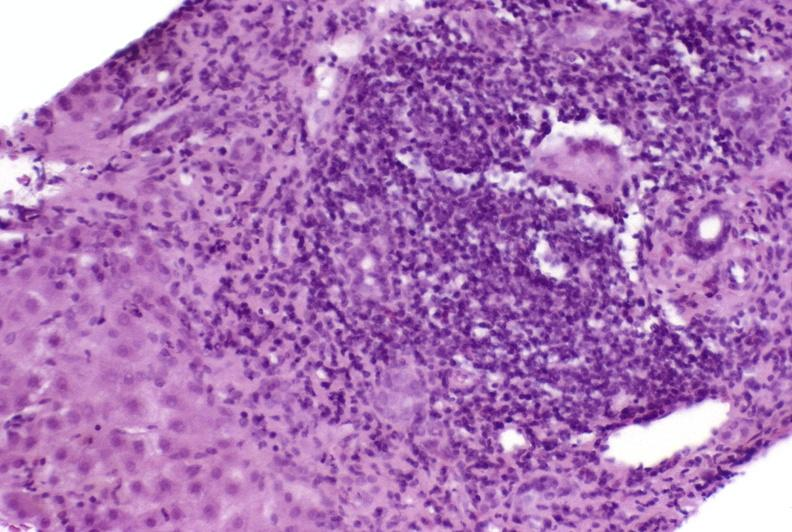does this image show autoimmune hepatitis?
Answer the question using a single word or phrase. Yes 